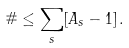<formula> <loc_0><loc_0><loc_500><loc_500>\# \leq \sum _ { s } [ A _ { s } - 1 ] \, .</formula> 